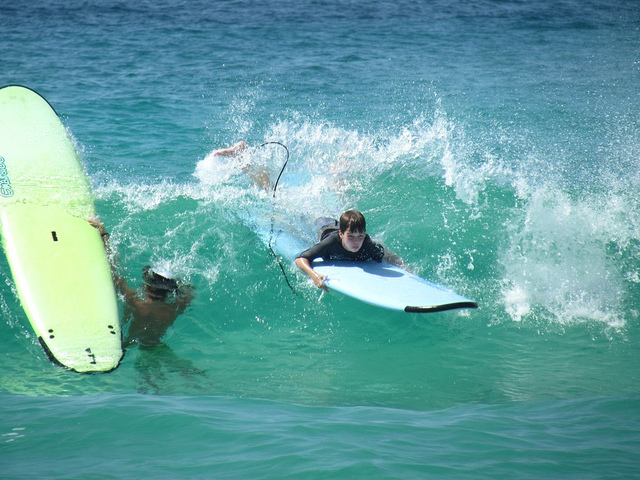<image>What is the name on the surfboard? I am not sure what the name on the surfboard is. It could be 'hobie', 'emerson', 'uber', 'quicksilver', or 'rs'. What is the name on the surfboard? There is no name on the surfboard. 